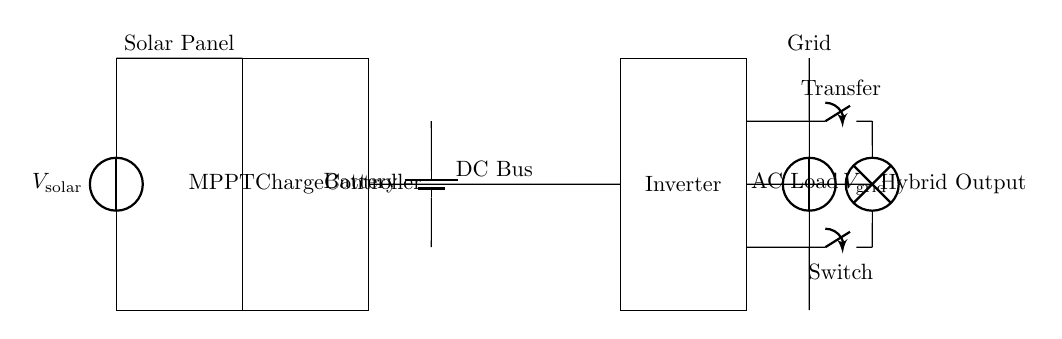What component converts DC to AC? The inverter is responsible for converting direct current (DC) from the battery and solar panel into alternating current (AC) suitable for powering household appliances.
Answer: Inverter What is the function of the MPPT charge controller? The Maximum Power Point Tracking (MPPT) charge controller optimizes the energy output from the solar panel by adjusting the electrical operating point to maximize power, then charges the battery.
Answer: Optimize energy Which component stores energy for backup power? The battery is the component designed to store electrical energy for use during outages or when solar power generation is not available.
Answer: Battery How many switches are in the circuit? There are two switches: one is the transfer switch which chooses between the grid and the inverter, and the second is a switch for the AC load output.
Answer: Two What is the role of the DC bus in the circuit? The DC bus provides a common electrical connection for the various DC components such as the solar panel, charge controller, and battery, allowing them to share energy efficiently.
Answer: Common connection During a power outage, what is the primary power source for the AC load? During a power outage, the inverter supplies power from the battery, which is charged by the solar panel or grid when available.
Answer: Battery What type of power does the solar panel produce? The solar panel generates direct current (DC) electricity from sunlight, which is then managed by the other components in the circuit.
Answer: Direct current 